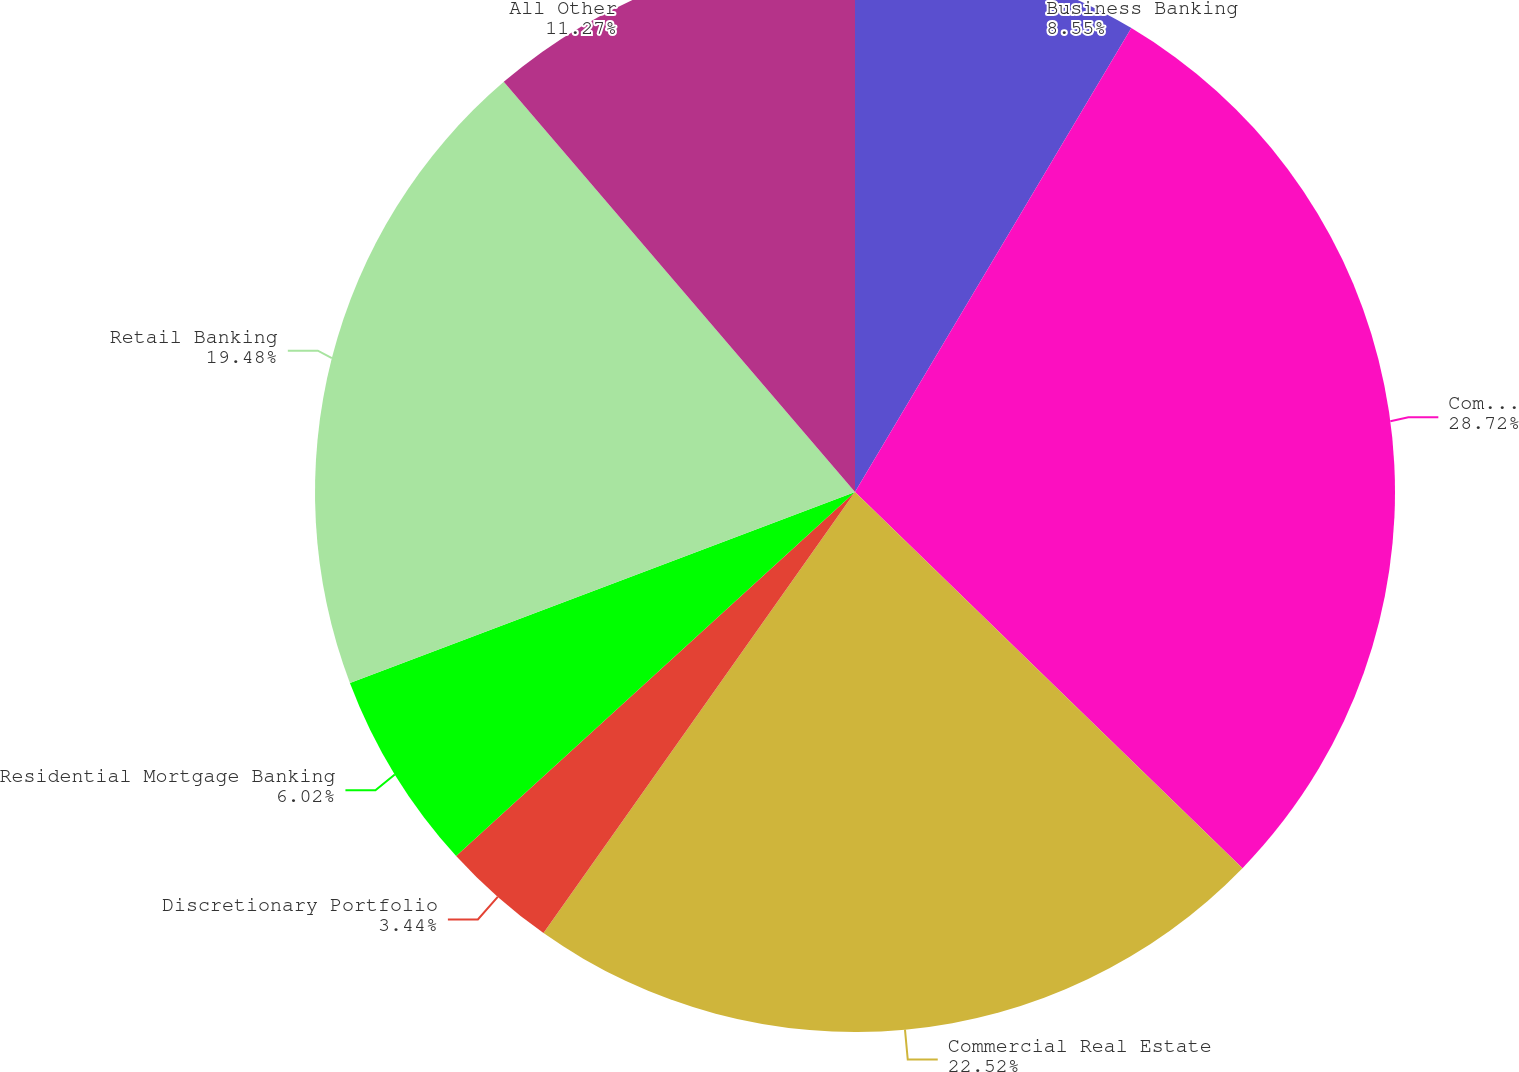Convert chart to OTSL. <chart><loc_0><loc_0><loc_500><loc_500><pie_chart><fcel>Business Banking<fcel>Commercial Banking<fcel>Commercial Real Estate<fcel>Discretionary Portfolio<fcel>Residential Mortgage Banking<fcel>Retail Banking<fcel>All Other<nl><fcel>8.55%<fcel>28.71%<fcel>22.52%<fcel>3.44%<fcel>6.02%<fcel>19.48%<fcel>11.27%<nl></chart> 